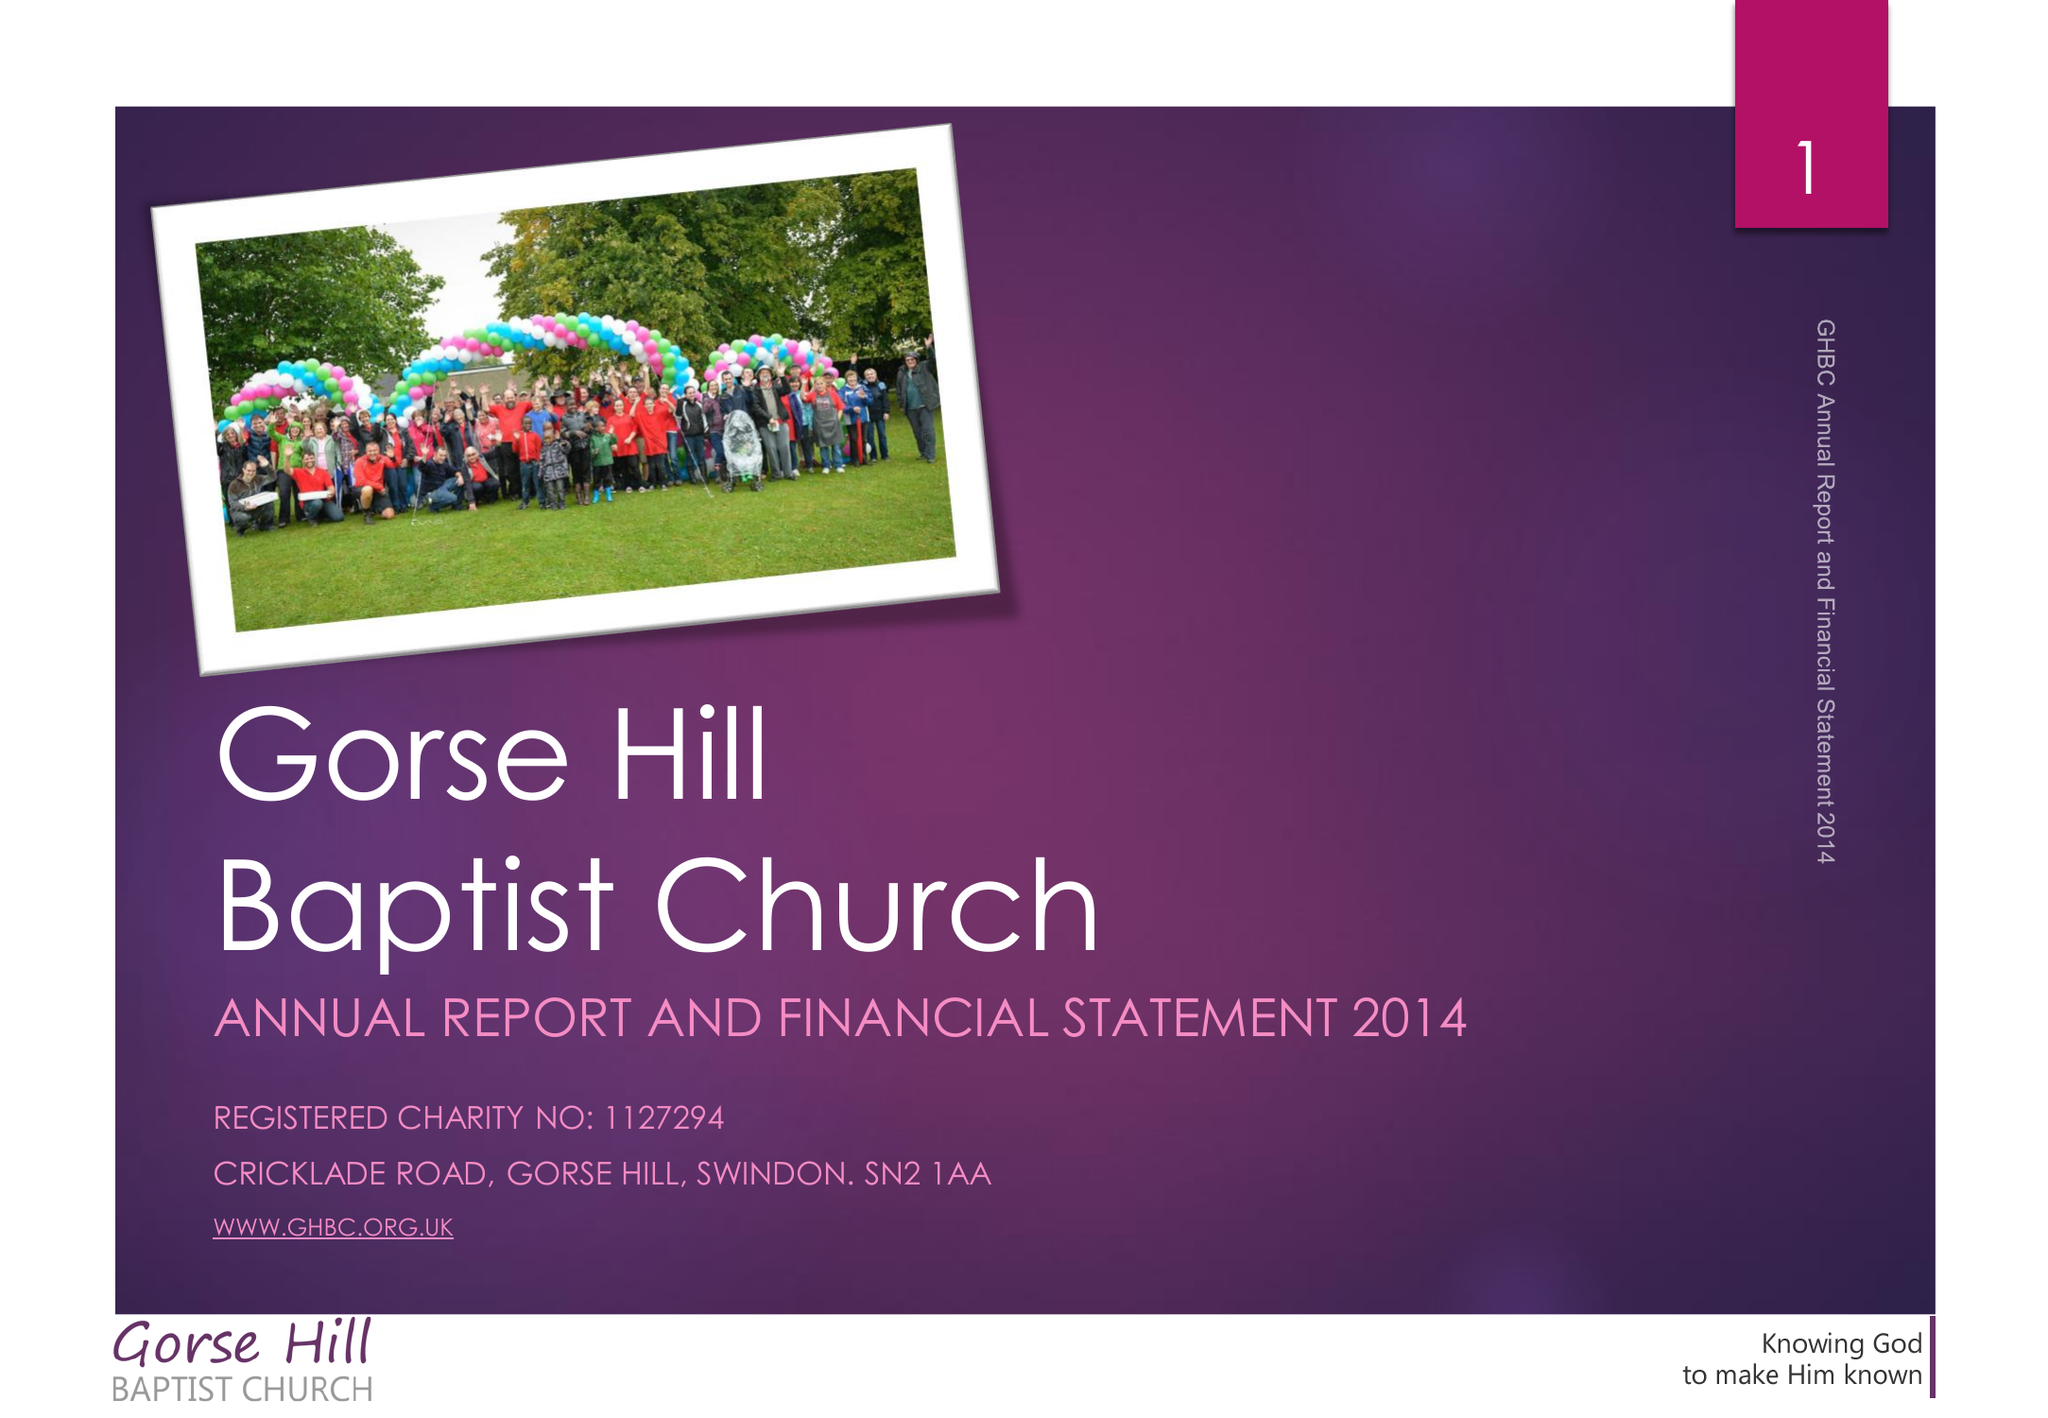What is the value for the spending_annually_in_british_pounds?
Answer the question using a single word or phrase. 168395.20 